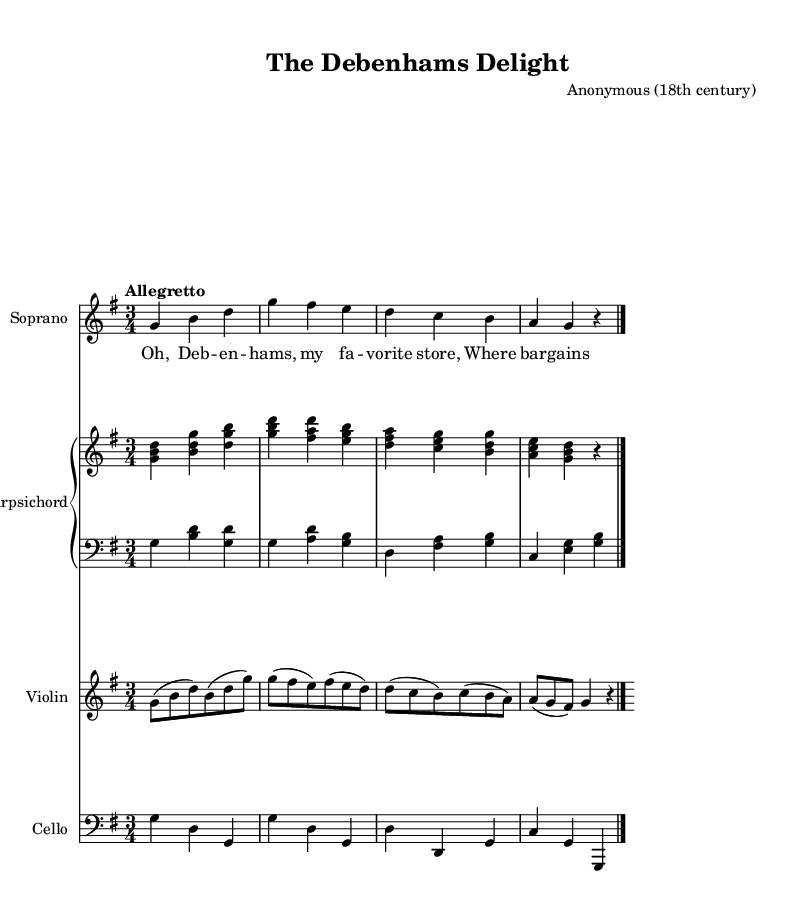What is the key signature of this music? The key signature is G major, which has one sharp (F#). This can be identified in the beginning of the staff where the sharp symbol is placed on the F line.
Answer: G major What is the time signature of this piece? The time signature is 3/4, indicated at the beginning of the score after the key signature. This means there are three beats in each measure, and the quarter note receives one beat.
Answer: 3/4 What is the tempo marking for this composition? The tempo marking is "Allegretto," which signifies that the piece should be played moderately fast. This can be found near the top of the music score, after the time signature.
Answer: Allegretto How many measures are in the soprano part? The soprano part contains four measures, which can be counted from the beginning to the end of the staff where the bar lines are present. Each measure is separated by a vertical line.
Answer: Four What instruments are included in the score? The instruments included are Soprano, Harpsichord (with left and right hands), Violin, and Cello. This can be seen at the beginning of each staff where the instruments are named.
Answer: Soprano, Harpsichord, Violin, Cello Which lyric corresponds to the first measure of the soprano part? The lyric corresponding to the first measure is "Oh, Deb," which can be matched to the notes played in that measure by referring to the lyrics beneath the notes on the staff.
Answer: Oh, Deb What type of opera is represented in this score? The score represents a light-hearted comic opera, as indicated by the playful lyrics and the lively tempo. This style is characteristic of the 18th-century comic opera genre.
Answer: Comic opera 